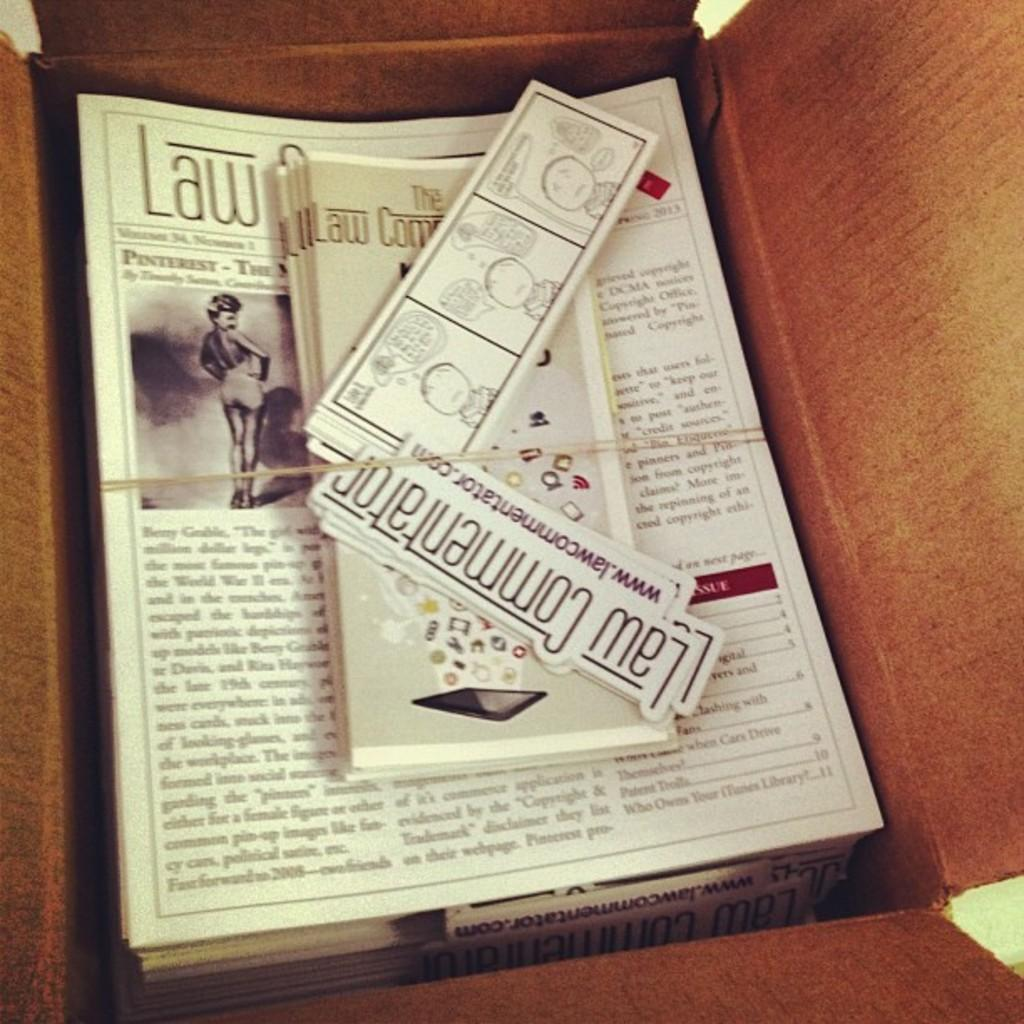<image>
Write a terse but informative summary of the picture. A box full of paper items for the Law Commentator. 